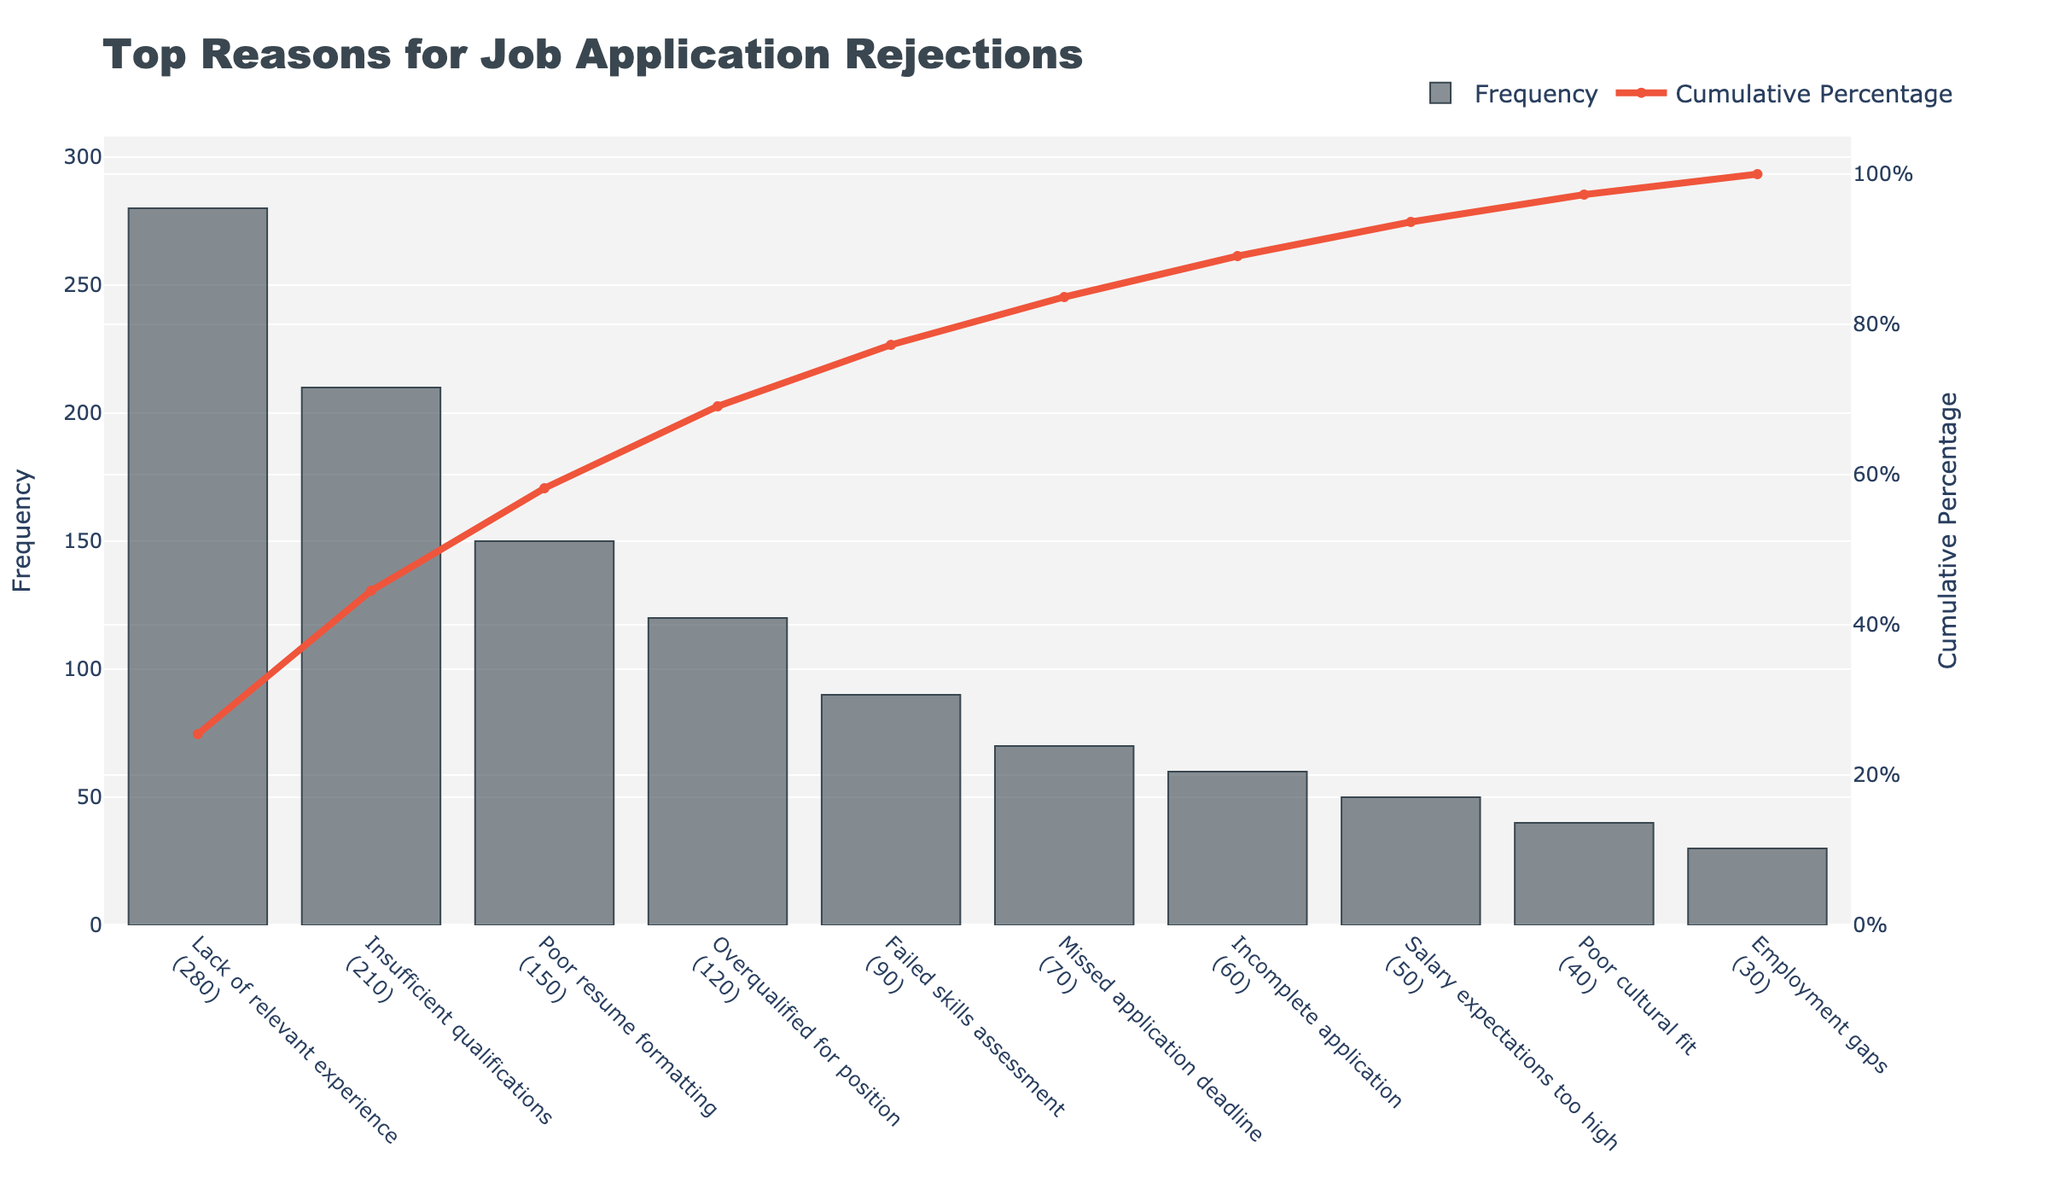What is the title of the figure? The title of the figure is presented prominently at the top and serves to summarize the main subject of the visualization.
Answer: Top Reasons for Job Application Rejections How many reasons are depicted in the bar chart? The number of reasons is the same as the number of bars in the bar chart. By counting the bars, we can determine the number of reasons.
Answer: 10 What is the cumulative percentage for the top three reasons combined? To find the cumulative percentage for the top three reasons, we add the individual cumulative percentages at the third bar. The cumulative percentages from the chart are summed up as 40% + 30% + 21.4%.
Answer: 91.4% Which reason has the highest frequency and what is its value? The reason with the highest frequency is the one associated with the tallest bar in the chart. Reading off the top of the tallest bar gives the frequency.
Answer: Lack of relevant experience, 280 Compare 'Failed skills assessment' and 'Incomplete application': which has a higher frequency and by how much? The frequencies for 'Failed skills assessment' and 'Incomplete application' can be read directly from their respective bars. 'Failed skills assessment' has a frequency of 90, and 'Incomplete application' has a frequency of 60. The difference is 90 - 60.
Answer: Failed skills assessment, 30 What is the cumulative percentage when the frequency is at 50? Looking at the cumulative percentage line and finding where it intersects the bar for 'Salary expectations too high' (which has a frequency of 50), we can read off the cumulative percentage.
Answer: 92.9% Which reason is responsible for reaching approximately 70% of cumulative percentage? The reason corresponding to approximately 70% cumulative percentage can be identified by locating the point on the cumulative line closest to 70% and tracing down to the x-axis.
Answer: Poor resume formatting What is the frequency range for the reasons depicted in the figure? The frequency range is determined by identifying the maximum and minimum frequencies among the reasons. The maximum is 280, and the minimum is 30. The range is the difference between these two values.
Answer: 30 to 280 Is there any reason with a frequency below 50? If yes, name it. By locating the bars that fall below the 50 mark on the y-axis, the corresponding reasons can be identified.
Answer: Poor cultural fit, Employment gaps Does 'Insufficient qualifications' contribute to more than or less than 50% of the cumulative percentage? The bar and corresponding cumulative percentage for 'Insufficient qualifications' need to be read. The cumulative percentage for it can be directly observed from the chart.
Answer: More than 50% 